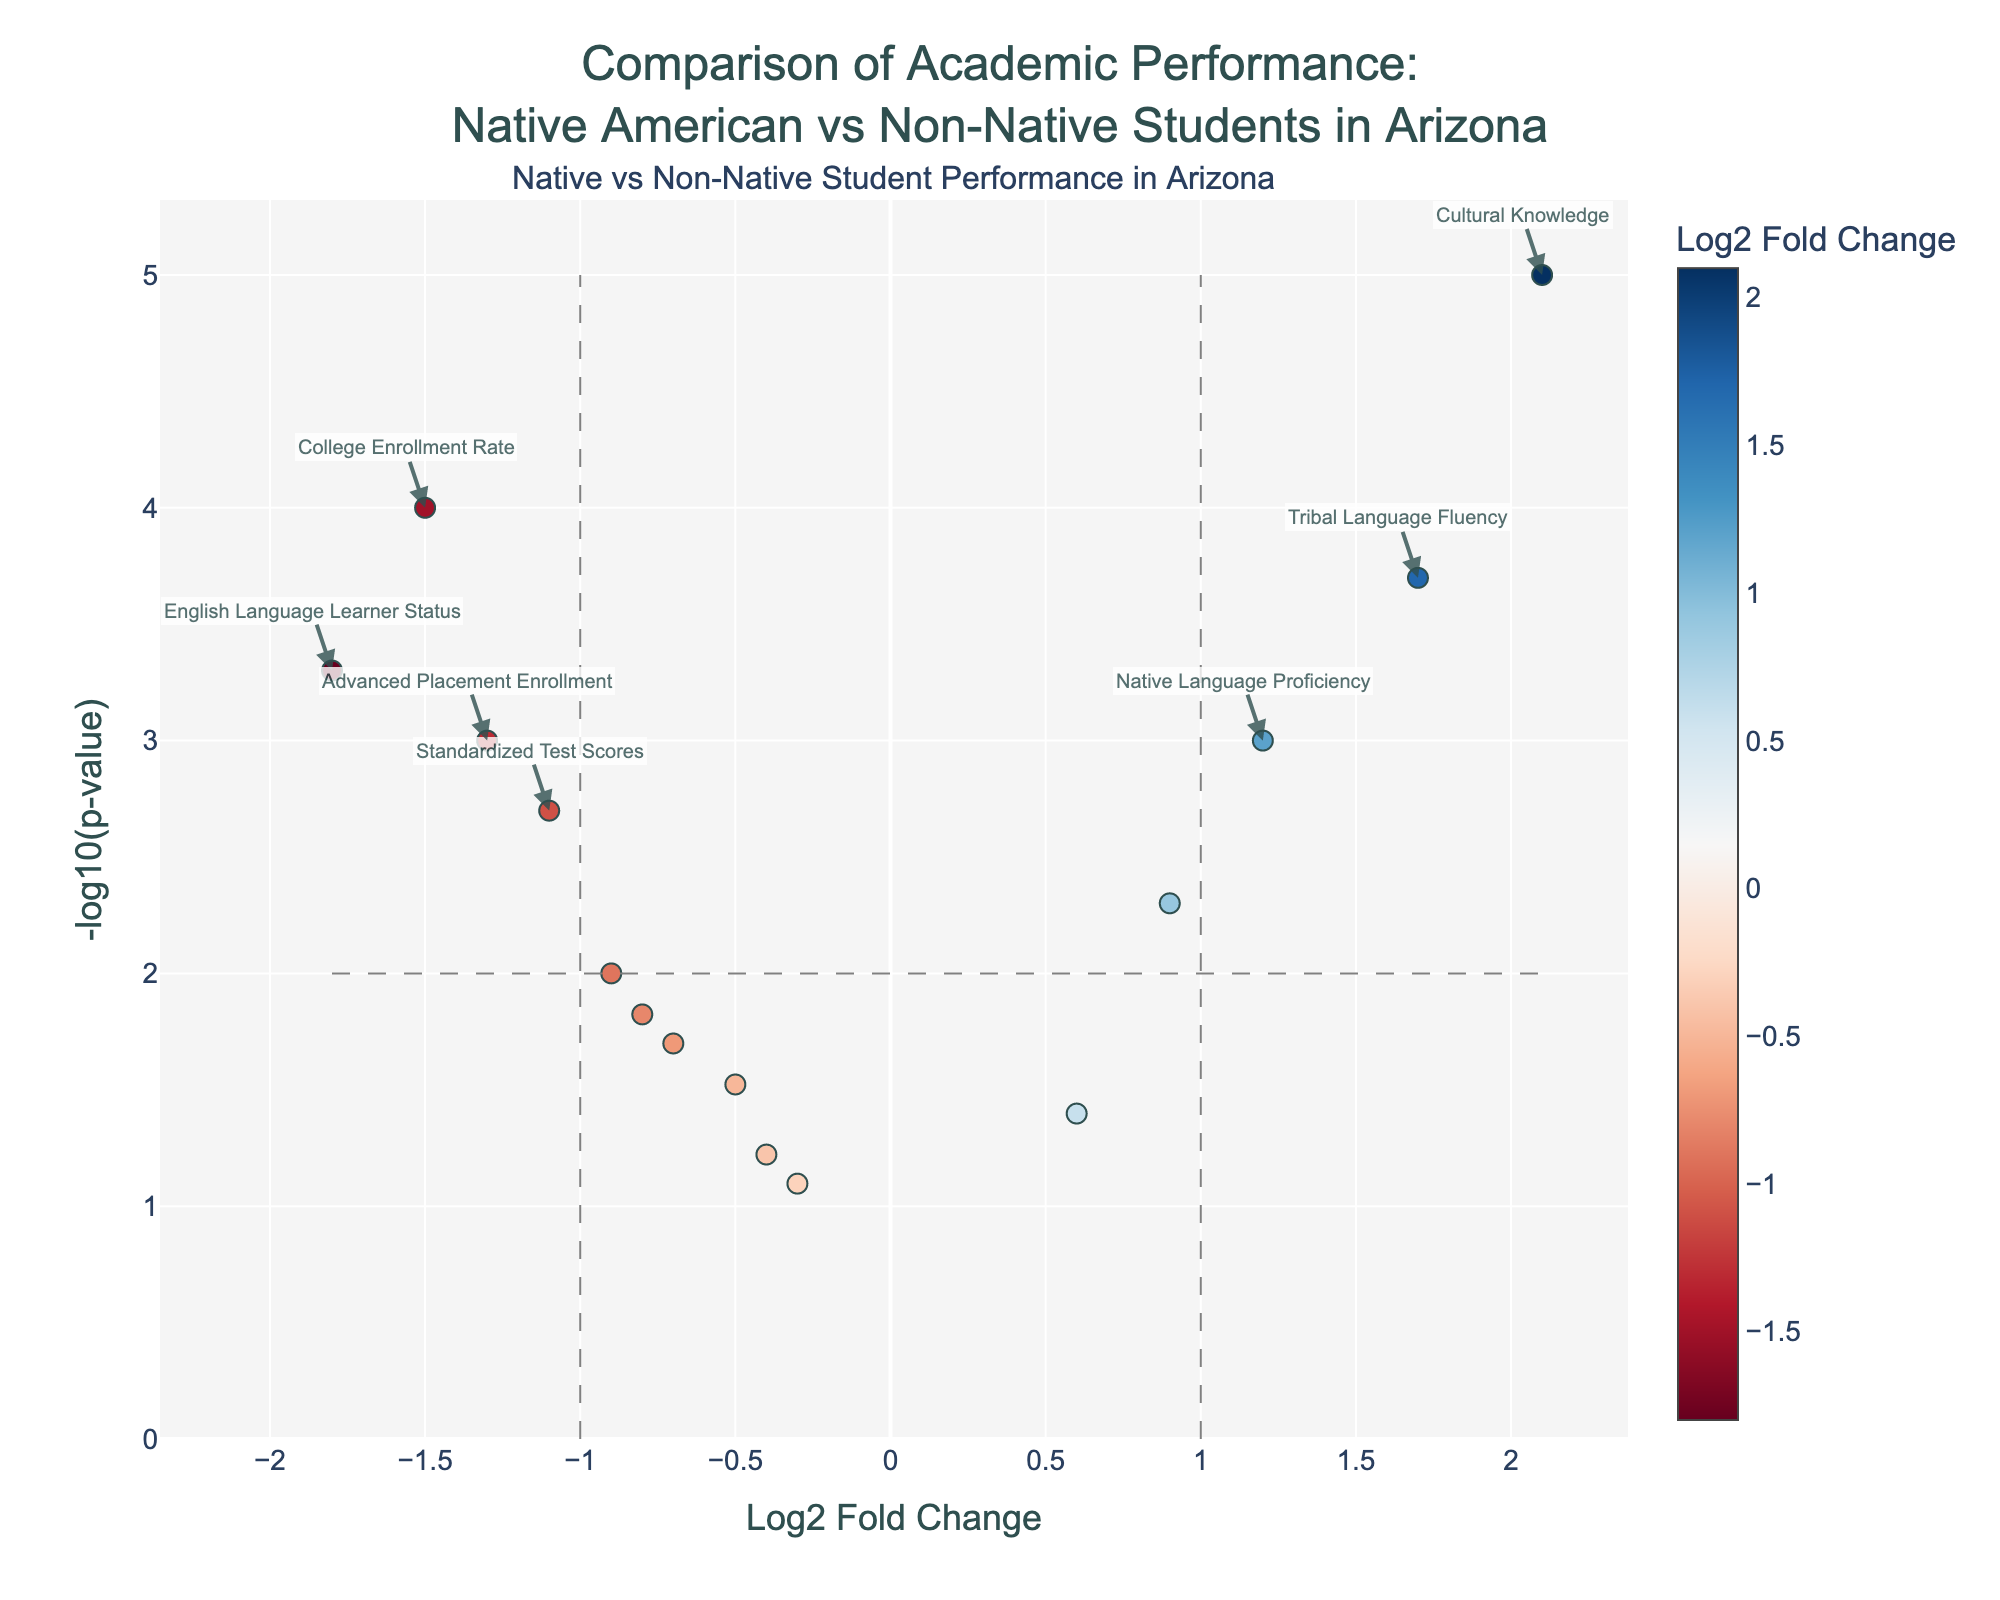How many data points have a Log2 Fold Change greater than 1? Count the number of points where the Log2 Fold Change value is greater than 1. There are three such points: Native Language Proficiency, Cultural Knowledge, and Tribal Language Fluency.
Answer: 3 Which metric has the highest Log2 Fold Change? Find the highest Log2 Fold Change value and identify the corresponding metric. Cultural Knowledge has the highest value at 2.1.
Answer: Cultural Knowledge What is the Log2 Fold Change for Mathematics Performance? Find Mathematics Performance in the table and read its Log2 Fold Change value, which is -0.8.
Answer: -0.8 Which data point has the lowest p-value? Identify the data point with the lowest p-value. Cultural Knowledge has the lowest p-value at 0.00001.
Answer: Cultural Knowledge Are there more points on the positive or negative side of the Log2 Fold Change axis? Count the number of points where Log2 Fold Change is positive and compare it with the number of points where it is negative. There are more points on the negative side.
Answer: Negative Which data point is closest to the origin (0,0)? Calculate the Euclidean distance of each point from the origin (0,0) and identify the smallest value. Science Achievement (-0.3, -log10(0.08)) is closest to the origin.
Answer: Science Achievement What is the Log2 Fold Change range for the High School Graduation Rate? Locate the High School Graduation Rate point and read its Log2 Fold Change value, which is -0.7. Since it's a single data point, the range is its value.
Answer: -0.7 Which points are more significant based on p-value (< 0.01)? Identify points with a p-value less than 0.01. These include College Enrollment Rate, Standardized Test Scores, Native Language Proficiency, History Knowledge, Cultural Knowledge, Tribal Language Fluency, and English Language Learner Status.
Answer: 7 Which metrics improve for Native American students relative to non-Native students? Identify points with a positive Log2 Fold Change value. These include Native Language Proficiency, History Knowledge, Extracurricular Participation, Cultural Knowledge, and Tribal Language Fluency.
Answer: 5 How many metrics have both a Log2 Fold Change > 1 and a p-value < 0.01? Filter points with both conditions (Log2 Fold Change > 1 and -log10(p-value) > 2). There are three such points: Native Language Proficiency, Cultural Knowledge, and Tribal Language Fluency.
Answer: 3 